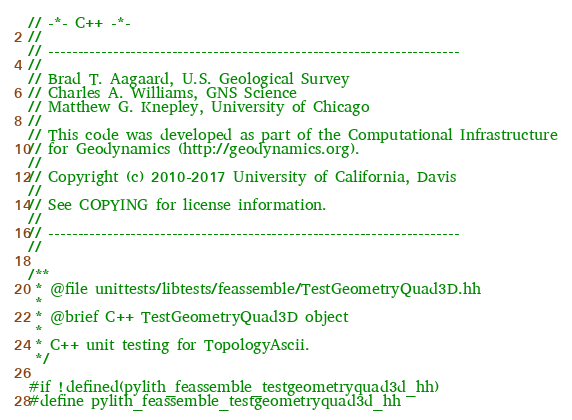Convert code to text. <code><loc_0><loc_0><loc_500><loc_500><_C++_>// -*- C++ -*-
//
// ----------------------------------------------------------------------
//
// Brad T. Aagaard, U.S. Geological Survey
// Charles A. Williams, GNS Science
// Matthew G. Knepley, University of Chicago
//
// This code was developed as part of the Computational Infrastructure
// for Geodynamics (http://geodynamics.org).
//
// Copyright (c) 2010-2017 University of California, Davis
//
// See COPYING for license information.
//
// ----------------------------------------------------------------------
//

/**
 * @file unittests/libtests/feassemble/TestGeometryQuad3D.hh
 *
 * @brief C++ TestGeometryQuad3D object
 *
 * C++ unit testing for TopologyAscii.
 */

#if !defined(pylith_feassemble_testgeometryquad3d_hh)
#define pylith_feassemble_testgeometryquad3d_hh
</code> 